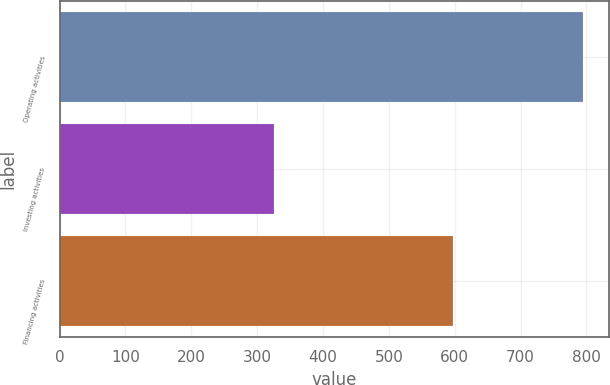<chart> <loc_0><loc_0><loc_500><loc_500><bar_chart><fcel>Operating activities<fcel>Investing activities<fcel>Financing activities<nl><fcel>794.1<fcel>325<fcel>597.8<nl></chart> 